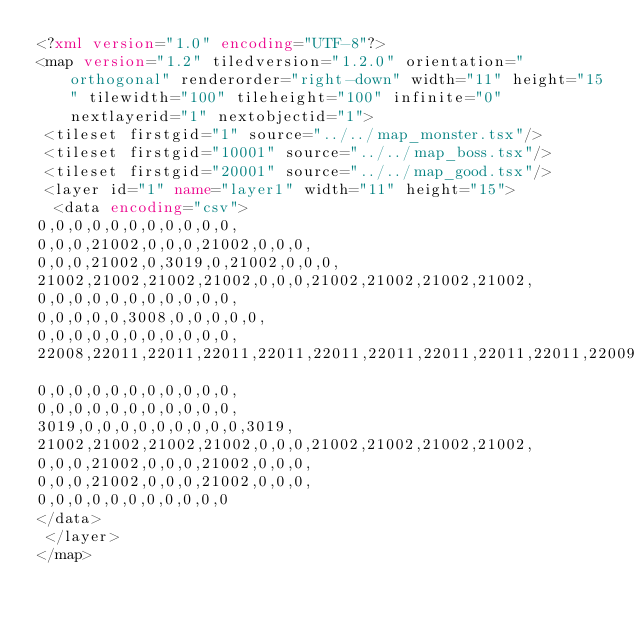Convert code to text. <code><loc_0><loc_0><loc_500><loc_500><_XML_><?xml version="1.0" encoding="UTF-8"?>
<map version="1.2" tiledversion="1.2.0" orientation="orthogonal" renderorder="right-down" width="11" height="15" tilewidth="100" tileheight="100" infinite="0" nextlayerid="1" nextobjectid="1">
 <tileset firstgid="1" source="../../map_monster.tsx"/>
 <tileset firstgid="10001" source="../../map_boss.tsx"/>
 <tileset firstgid="20001" source="../../map_good.tsx"/>
 <layer id="1" name="layer1" width="11" height="15">
  <data encoding="csv">
0,0,0,0,0,0,0,0,0,0,0,
0,0,0,21002,0,0,0,21002,0,0,0,
0,0,0,21002,0,3019,0,21002,0,0,0,
21002,21002,21002,21002,0,0,0,21002,21002,21002,21002,
0,0,0,0,0,0,0,0,0,0,0,
0,0,0,0,0,3008,0,0,0,0,0,
0,0,0,0,0,0,0,0,0,0,0,
22008,22011,22011,22011,22011,22011,22011,22011,22011,22011,22009,
0,0,0,0,0,0,0,0,0,0,0,
0,0,0,0,0,0,0,0,0,0,0,
3019,0,0,0,0,0,0,0,0,0,3019,
21002,21002,21002,21002,0,0,0,21002,21002,21002,21002,
0,0,0,21002,0,0,0,21002,0,0,0,
0,0,0,21002,0,0,0,21002,0,0,0,
0,0,0,0,0,0,0,0,0,0,0
</data>
 </layer>
</map>
</code> 